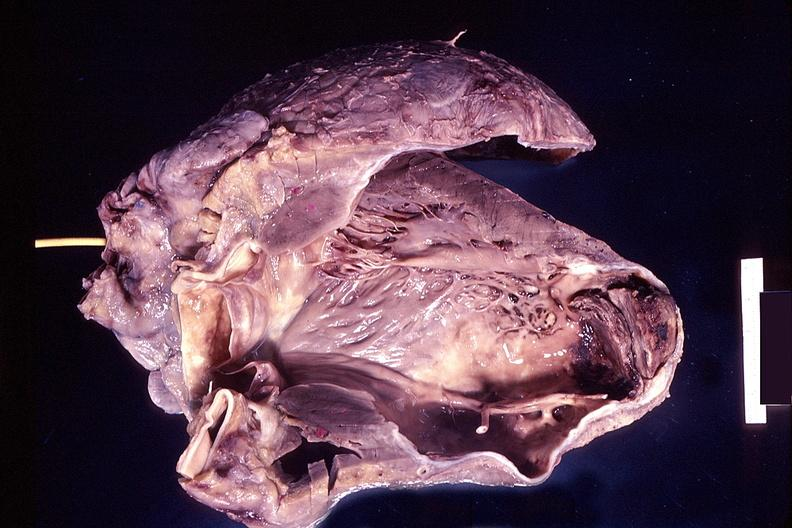s quite good liver present?
Answer the question using a single word or phrase. No 